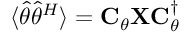<formula> <loc_0><loc_0><loc_500><loc_500>\langle \widehat { \theta } \widehat { \theta } ^ { H } \rangle = C _ { \theta } X C _ { \theta } ^ { \dagger }</formula> 